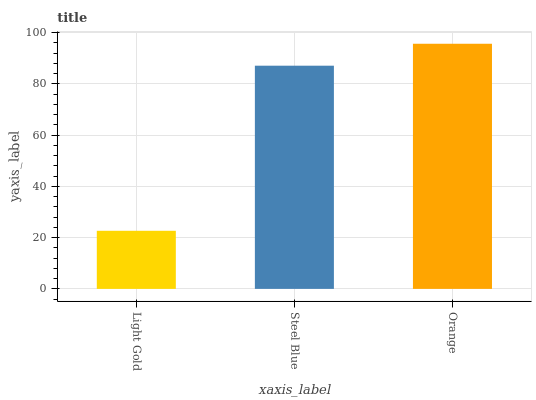Is Light Gold the minimum?
Answer yes or no. Yes. Is Orange the maximum?
Answer yes or no. Yes. Is Steel Blue the minimum?
Answer yes or no. No. Is Steel Blue the maximum?
Answer yes or no. No. Is Steel Blue greater than Light Gold?
Answer yes or no. Yes. Is Light Gold less than Steel Blue?
Answer yes or no. Yes. Is Light Gold greater than Steel Blue?
Answer yes or no. No. Is Steel Blue less than Light Gold?
Answer yes or no. No. Is Steel Blue the high median?
Answer yes or no. Yes. Is Steel Blue the low median?
Answer yes or no. Yes. Is Orange the high median?
Answer yes or no. No. Is Light Gold the low median?
Answer yes or no. No. 